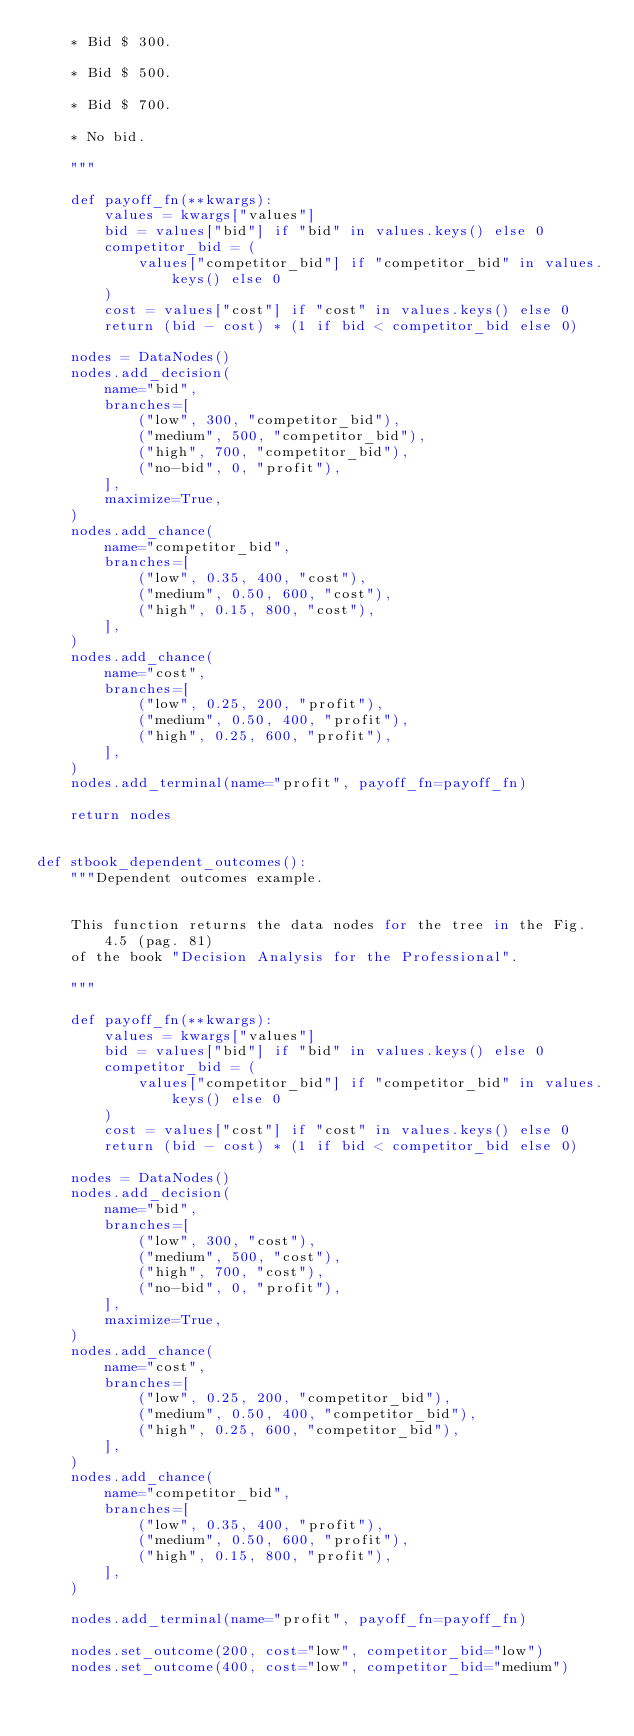<code> <loc_0><loc_0><loc_500><loc_500><_Python_>    * Bid $ 300.

    * Bid $ 500.

    * Bid $ 700.

    * No bid.

    """

    def payoff_fn(**kwargs):
        values = kwargs["values"]
        bid = values["bid"] if "bid" in values.keys() else 0
        competitor_bid = (
            values["competitor_bid"] if "competitor_bid" in values.keys() else 0
        )
        cost = values["cost"] if "cost" in values.keys() else 0
        return (bid - cost) * (1 if bid < competitor_bid else 0)

    nodes = DataNodes()
    nodes.add_decision(
        name="bid",
        branches=[
            ("low", 300, "competitor_bid"),
            ("medium", 500, "competitor_bid"),
            ("high", 700, "competitor_bid"),
            ("no-bid", 0, "profit"),
        ],
        maximize=True,
    )
    nodes.add_chance(
        name="competitor_bid",
        branches=[
            ("low", 0.35, 400, "cost"),
            ("medium", 0.50, 600, "cost"),
            ("high", 0.15, 800, "cost"),
        ],
    )
    nodes.add_chance(
        name="cost",
        branches=[
            ("low", 0.25, 200, "profit"),
            ("medium", 0.50, 400, "profit"),
            ("high", 0.25, 600, "profit"),
        ],
    )
    nodes.add_terminal(name="profit", payoff_fn=payoff_fn)

    return nodes


def stbook_dependent_outcomes():
    """Dependent outcomes example.


    This function returns the data nodes for the tree in the Fig. 4.5 (pag. 81)
    of the book "Decision Analysis for the Professional".

    """

    def payoff_fn(**kwargs):
        values = kwargs["values"]
        bid = values["bid"] if "bid" in values.keys() else 0
        competitor_bid = (
            values["competitor_bid"] if "competitor_bid" in values.keys() else 0
        )
        cost = values["cost"] if "cost" in values.keys() else 0
        return (bid - cost) * (1 if bid < competitor_bid else 0)

    nodes = DataNodes()
    nodes.add_decision(
        name="bid",
        branches=[
            ("low", 300, "cost"),
            ("medium", 500, "cost"),
            ("high", 700, "cost"),
            ("no-bid", 0, "profit"),
        ],
        maximize=True,
    )
    nodes.add_chance(
        name="cost",
        branches=[
            ("low", 0.25, 200, "competitor_bid"),
            ("medium", 0.50, 400, "competitor_bid"),
            ("high", 0.25, 600, "competitor_bid"),
        ],
    )
    nodes.add_chance(
        name="competitor_bid",
        branches=[
            ("low", 0.35, 400, "profit"),
            ("medium", 0.50, 600, "profit"),
            ("high", 0.15, 800, "profit"),
        ],
    )

    nodes.add_terminal(name="profit", payoff_fn=payoff_fn)

    nodes.set_outcome(200, cost="low", competitor_bid="low")
    nodes.set_outcome(400, cost="low", competitor_bid="medium")</code> 